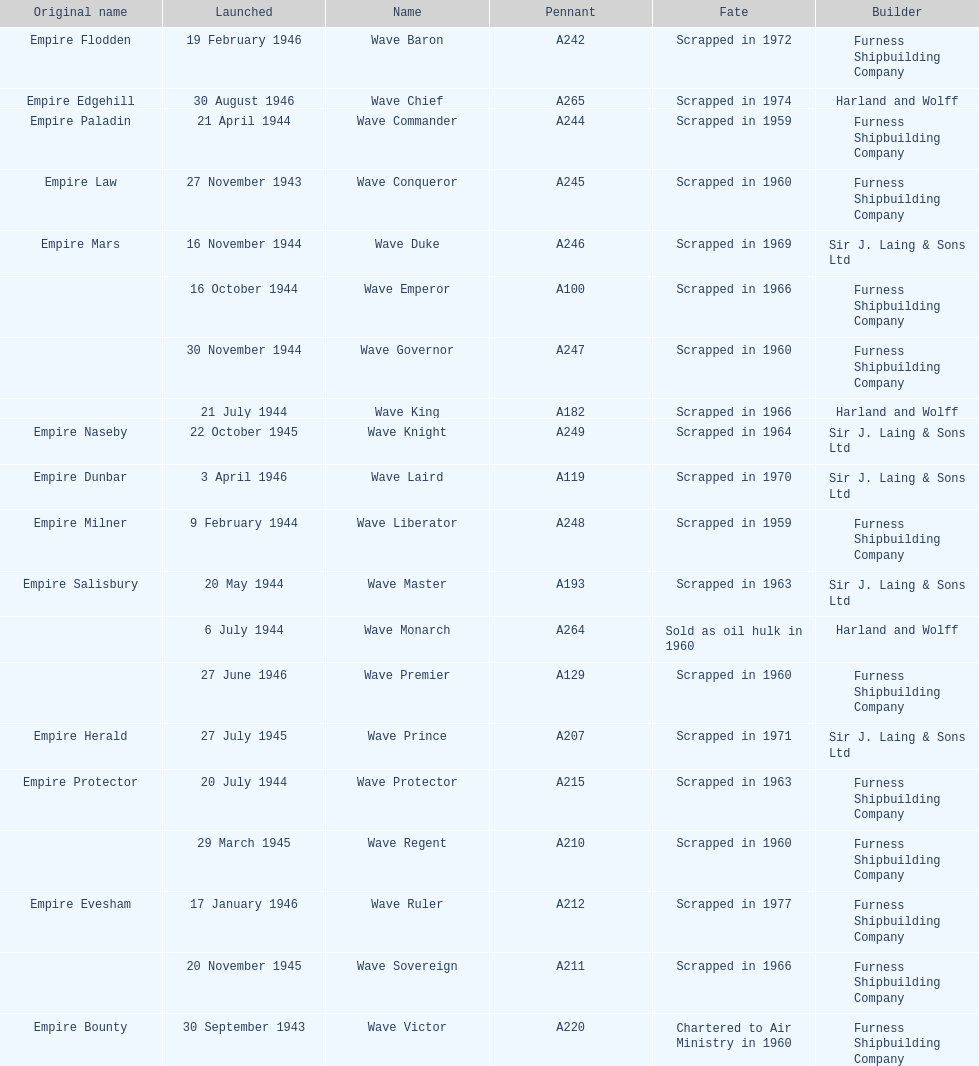Would you be able to parse every entry in this table? {'header': ['Original name', 'Launched', 'Name', 'Pennant', 'Fate', 'Builder'], 'rows': [['Empire Flodden', '19 February 1946', 'Wave Baron', 'A242', 'Scrapped in 1972', 'Furness Shipbuilding Company'], ['Empire Edgehill', '30 August 1946', 'Wave Chief', 'A265', 'Scrapped in 1974', 'Harland and Wolff'], ['Empire Paladin', '21 April 1944', 'Wave Commander', 'A244', 'Scrapped in 1959', 'Furness Shipbuilding Company'], ['Empire Law', '27 November 1943', 'Wave Conqueror', 'A245', 'Scrapped in 1960', 'Furness Shipbuilding Company'], ['Empire Mars', '16 November 1944', 'Wave Duke', 'A246', 'Scrapped in 1969', 'Sir J. Laing & Sons Ltd'], ['', '16 October 1944', 'Wave Emperor', 'A100', 'Scrapped in 1966', 'Furness Shipbuilding Company'], ['', '30 November 1944', 'Wave Governor', 'A247', 'Scrapped in 1960', 'Furness Shipbuilding Company'], ['', '21 July 1944', 'Wave King', 'A182', 'Scrapped in 1966', 'Harland and Wolff'], ['Empire Naseby', '22 October 1945', 'Wave Knight', 'A249', 'Scrapped in 1964', 'Sir J. Laing & Sons Ltd'], ['Empire Dunbar', '3 April 1946', 'Wave Laird', 'A119', 'Scrapped in 1970', 'Sir J. Laing & Sons Ltd'], ['Empire Milner', '9 February 1944', 'Wave Liberator', 'A248', 'Scrapped in 1959', 'Furness Shipbuilding Company'], ['Empire Salisbury', '20 May 1944', 'Wave Master', 'A193', 'Scrapped in 1963', 'Sir J. Laing & Sons Ltd'], ['', '6 July 1944', 'Wave Monarch', 'A264', 'Sold as oil hulk in 1960', 'Harland and Wolff'], ['', '27 June 1946', 'Wave Premier', 'A129', 'Scrapped in 1960', 'Furness Shipbuilding Company'], ['Empire Herald', '27 July 1945', 'Wave Prince', 'A207', 'Scrapped in 1971', 'Sir J. Laing & Sons Ltd'], ['Empire Protector', '20 July 1944', 'Wave Protector', 'A215', 'Scrapped in 1963', 'Furness Shipbuilding Company'], ['', '29 March 1945', 'Wave Regent', 'A210', 'Scrapped in 1960', 'Furness Shipbuilding Company'], ['Empire Evesham', '17 January 1946', 'Wave Ruler', 'A212', 'Scrapped in 1977', 'Furness Shipbuilding Company'], ['', '20 November 1945', 'Wave Sovereign', 'A211', 'Scrapped in 1966', 'Furness Shipbuilding Company'], ['Empire Bounty', '30 September 1943', 'Wave Victor', 'A220', 'Chartered to Air Ministry in 1960', 'Furness Shipbuilding Company']]} Name a builder with "and" in the name. Harland and Wolff. 